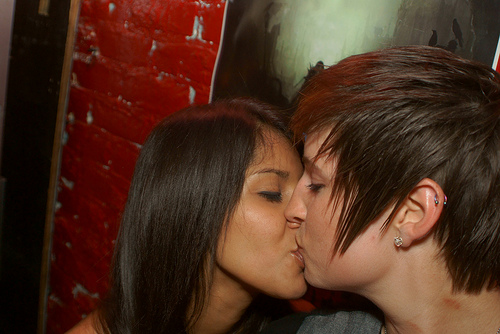<image>
Is there a boy on the girl? No. The boy is not positioned on the girl. They may be near each other, but the boy is not supported by or resting on top of the girl. Is there a wall behind the woman? Yes. From this viewpoint, the wall is positioned behind the woman, with the woman partially or fully occluding the wall. Is the brunette in front of the redhead? Yes. The brunette is positioned in front of the redhead, appearing closer to the camera viewpoint. 